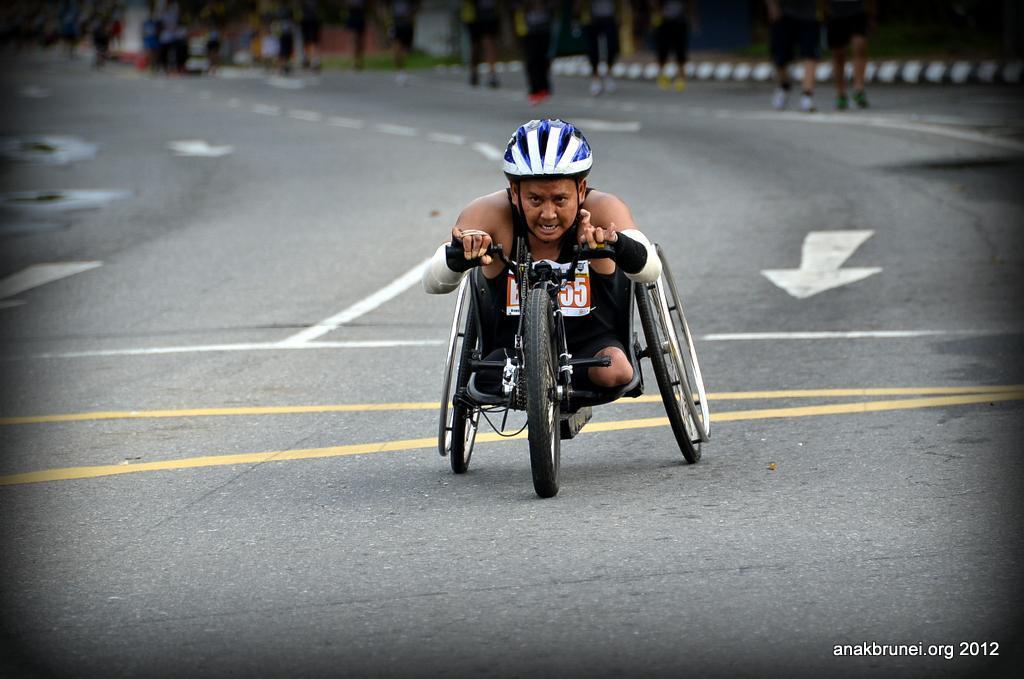How would you summarize this image in a sentence or two? In this picture we can see a man wore a helmet and riding a wheelchair on the road and in the background we can see some people walking, trees and it is blurry. 